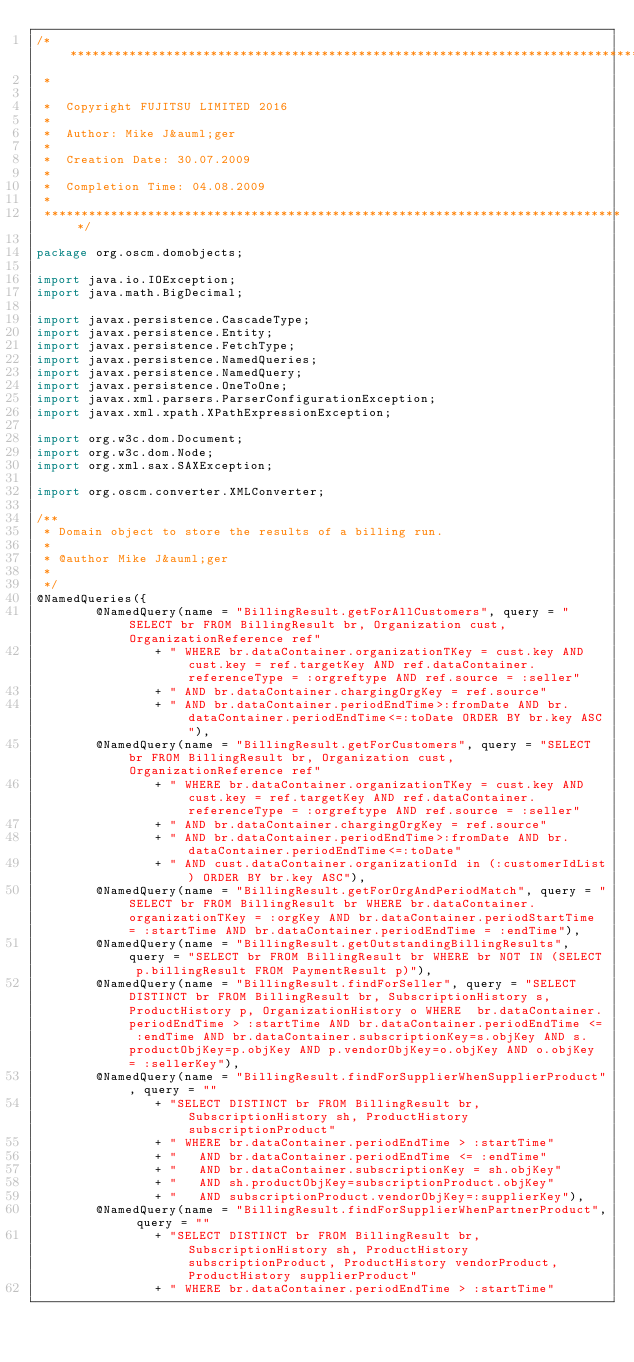<code> <loc_0><loc_0><loc_500><loc_500><_Java_>/*******************************************************************************
 *                                                                              

 *  Copyright FUJITSU LIMITED 2016                                             
 *                                                                              
 *  Author: Mike J&auml;ger                                                      
 *                                                                              
 *  Creation Date: 30.07.2009                                                      
 *                                                                              
 *  Completion Time: 04.08.2009                                              
 *                                                                              
 *******************************************************************************/

package org.oscm.domobjects;

import java.io.IOException;
import java.math.BigDecimal;

import javax.persistence.CascadeType;
import javax.persistence.Entity;
import javax.persistence.FetchType;
import javax.persistence.NamedQueries;
import javax.persistence.NamedQuery;
import javax.persistence.OneToOne;
import javax.xml.parsers.ParserConfigurationException;
import javax.xml.xpath.XPathExpressionException;

import org.w3c.dom.Document;
import org.w3c.dom.Node;
import org.xml.sax.SAXException;

import org.oscm.converter.XMLConverter;

/**
 * Domain object to store the results of a billing run.
 * 
 * @author Mike J&auml;ger
 * 
 */
@NamedQueries({
        @NamedQuery(name = "BillingResult.getForAllCustomers", query = "SELECT br FROM BillingResult br, Organization cust, OrganizationReference ref"
                + " WHERE br.dataContainer.organizationTKey = cust.key AND cust.key = ref.targetKey AND ref.dataContainer.referenceType = :orgreftype AND ref.source = :seller"
                + " AND br.dataContainer.chargingOrgKey = ref.source"
                + " AND br.dataContainer.periodEndTime>:fromDate AND br.dataContainer.periodEndTime<=:toDate ORDER BY br.key ASC"),
        @NamedQuery(name = "BillingResult.getForCustomers", query = "SELECT br FROM BillingResult br, Organization cust, OrganizationReference ref"
                + " WHERE br.dataContainer.organizationTKey = cust.key AND cust.key = ref.targetKey AND ref.dataContainer.referenceType = :orgreftype AND ref.source = :seller"
                + " AND br.dataContainer.chargingOrgKey = ref.source"
                + " AND br.dataContainer.periodEndTime>:fromDate AND br.dataContainer.periodEndTime<=:toDate"
                + " AND cust.dataContainer.organizationId in (:customerIdList) ORDER BY br.key ASC"),
        @NamedQuery(name = "BillingResult.getForOrgAndPeriodMatch", query = "SELECT br FROM BillingResult br WHERE br.dataContainer.organizationTKey = :orgKey AND br.dataContainer.periodStartTime = :startTime AND br.dataContainer.periodEndTime = :endTime"),
        @NamedQuery(name = "BillingResult.getOutstandingBillingResults", query = "SELECT br FROM BillingResult br WHERE br NOT IN (SELECT p.billingResult FROM PaymentResult p)"),
        @NamedQuery(name = "BillingResult.findForSeller", query = "SELECT DISTINCT br FROM BillingResult br, SubscriptionHistory s, ProductHistory p, OrganizationHistory o WHERE  br.dataContainer.periodEndTime > :startTime AND br.dataContainer.periodEndTime <= :endTime AND br.dataContainer.subscriptionKey=s.objKey AND s.productObjKey=p.objKey AND p.vendorObjKey=o.objKey AND o.objKey = :sellerKey"),
        @NamedQuery(name = "BillingResult.findForSupplierWhenSupplierProduct", query = ""
                + "SELECT DISTINCT br FROM BillingResult br, SubscriptionHistory sh, ProductHistory subscriptionProduct"
                + " WHERE br.dataContainer.periodEndTime > :startTime"
                + "   AND br.dataContainer.periodEndTime <= :endTime"
                + "   AND br.dataContainer.subscriptionKey = sh.objKey"
                + "   AND sh.productObjKey=subscriptionProduct.objKey"
                + "   AND subscriptionProduct.vendorObjKey=:supplierKey"),
        @NamedQuery(name = "BillingResult.findForSupplierWhenPartnerProduct", query = ""
                + "SELECT DISTINCT br FROM BillingResult br, SubscriptionHistory sh, ProductHistory subscriptionProduct, ProductHistory vendorProduct, ProductHistory supplierProduct"
                + " WHERE br.dataContainer.periodEndTime > :startTime"</code> 